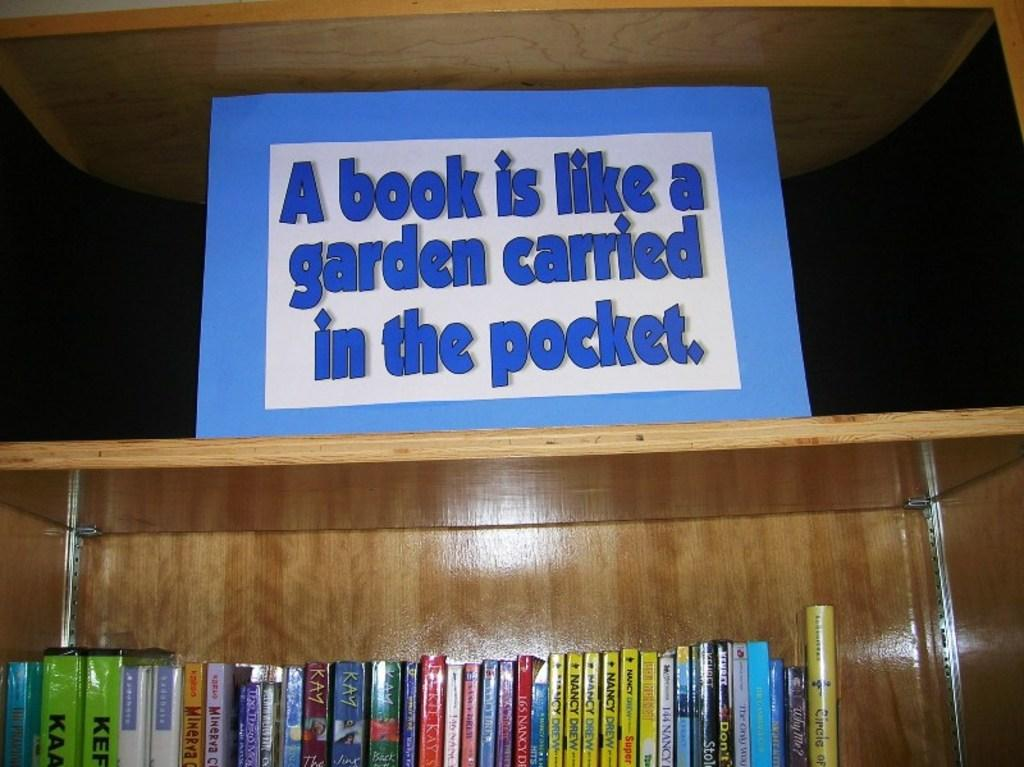<image>
Create a compact narrative representing the image presented. A book shelf with a blue sign on top that says A book is like a garden carried in the pocket. 